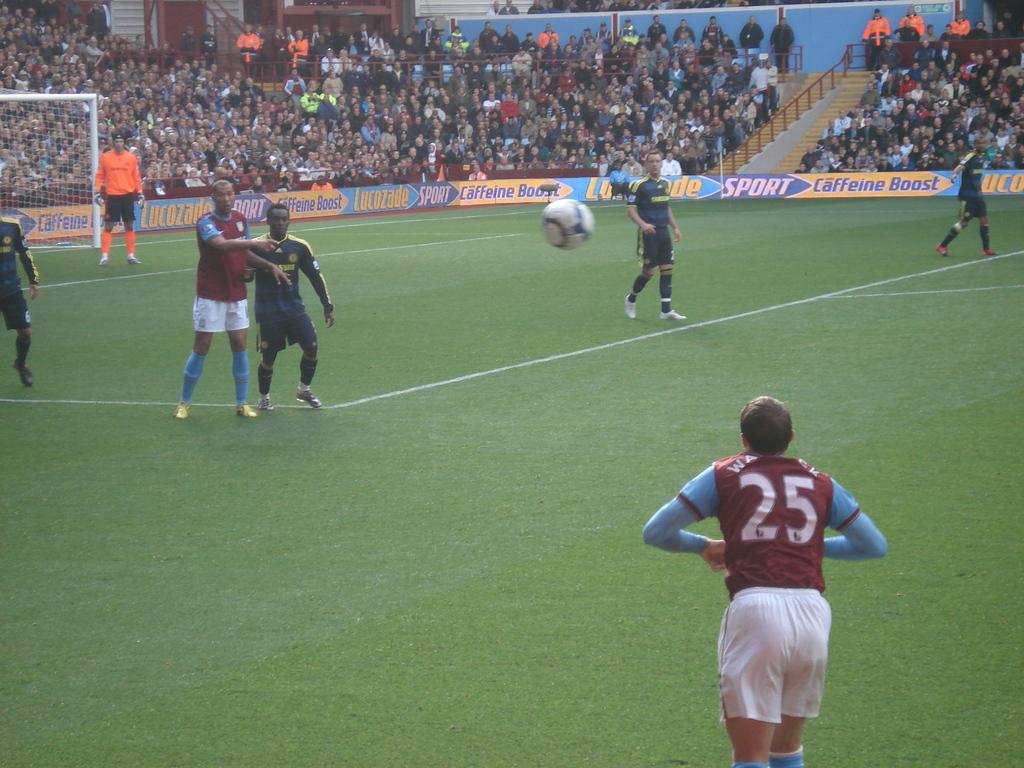What is the mans number who just threw in the ball?
Provide a succinct answer. 25. What number is on the jersey of the person with their back to camera?
Your response must be concise. 25. 